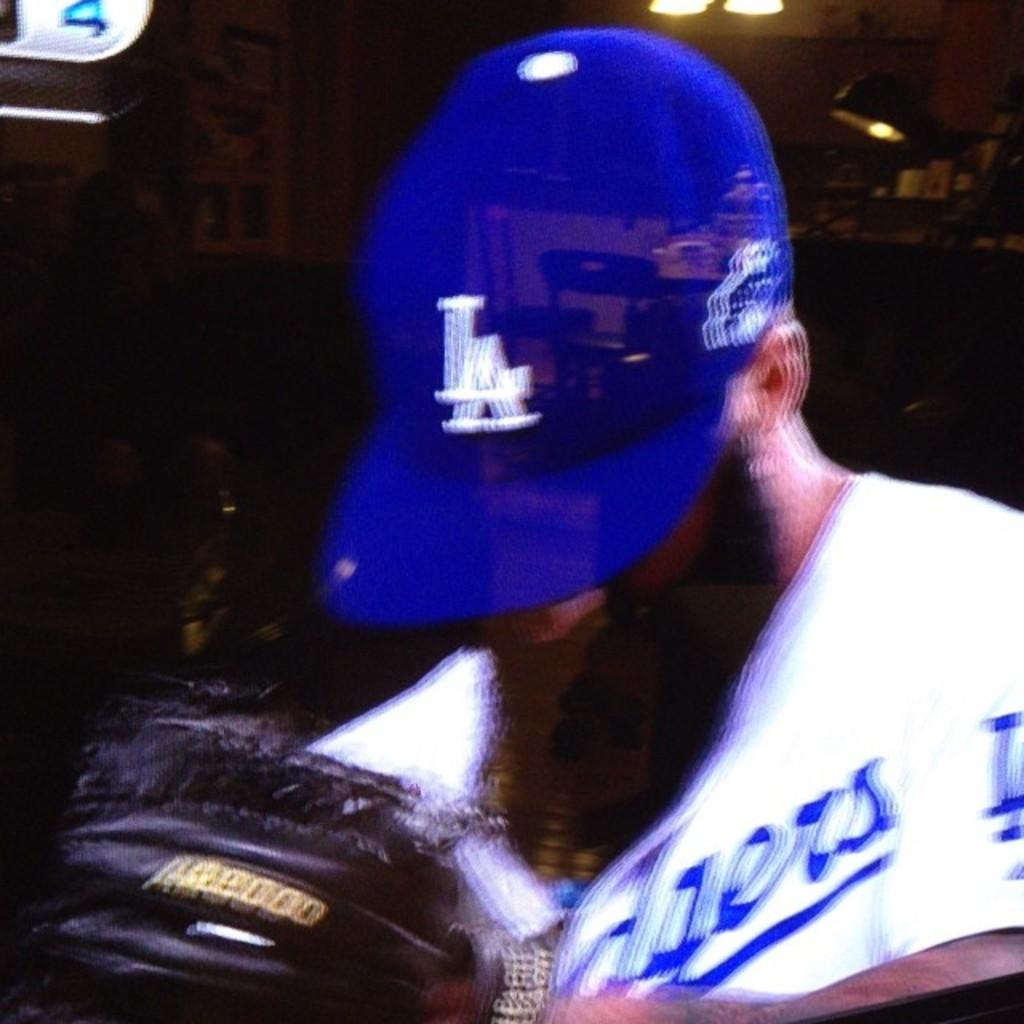Who is present in the image? There is a man in the image. What is the man wearing on his head? The man is wearing a blue cap. What type of shirt is the man wearing? The man is wearing a white t-shirt. What can be seen at the top of the image? There are lights visible at the top of the image. What type of knot is the man tying in the image? There is no knot-tying activity depicted in the image. How much income does the man's uncle have in the image? There is no information about the man's uncle or his income in the image. 